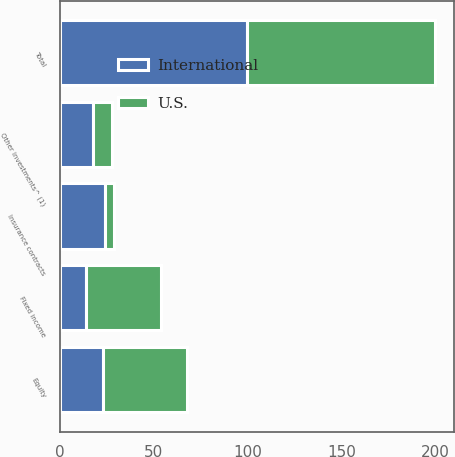Convert chart. <chart><loc_0><loc_0><loc_500><loc_500><stacked_bar_chart><ecel><fcel>Equity<fcel>Fixed income<fcel>Insurance contracts<fcel>Other investments^ (1)<fcel>Total<nl><fcel>U.S.<fcel>45<fcel>40<fcel>5<fcel>10<fcel>100<nl><fcel>International<fcel>23<fcel>14<fcel>24<fcel>18<fcel>100<nl></chart> 